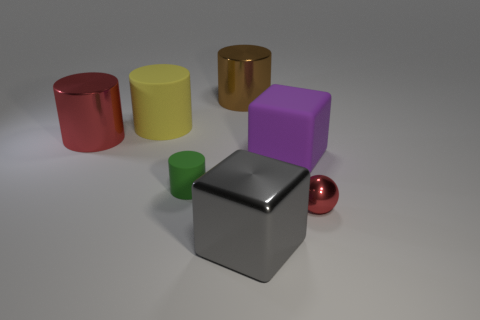What size is the yellow thing?
Your answer should be compact. Large. Does the brown metallic cylinder have the same size as the metallic thing on the left side of the large yellow cylinder?
Give a very brief answer. Yes. The block on the left side of the rubber thing that is on the right side of the big shiny object that is on the right side of the brown thing is what color?
Your answer should be compact. Gray. Is the big gray block that is in front of the big red cylinder made of the same material as the small sphere?
Offer a very short reply. Yes. What number of other objects are there of the same material as the gray object?
Ensure brevity in your answer.  3. There is a purple thing that is the same size as the brown object; what is its material?
Ensure brevity in your answer.  Rubber. There is a red thing left of the large gray metal block; does it have the same shape as the big rubber thing that is to the left of the gray shiny thing?
Make the answer very short. Yes. There is a red thing that is the same size as the green rubber object; what shape is it?
Give a very brief answer. Sphere. Is the material of the red object to the right of the gray cube the same as the big block in front of the tiny cylinder?
Your response must be concise. Yes. Is there a large rubber object that is to the left of the matte cylinder that is in front of the large purple matte object?
Keep it short and to the point. Yes. 